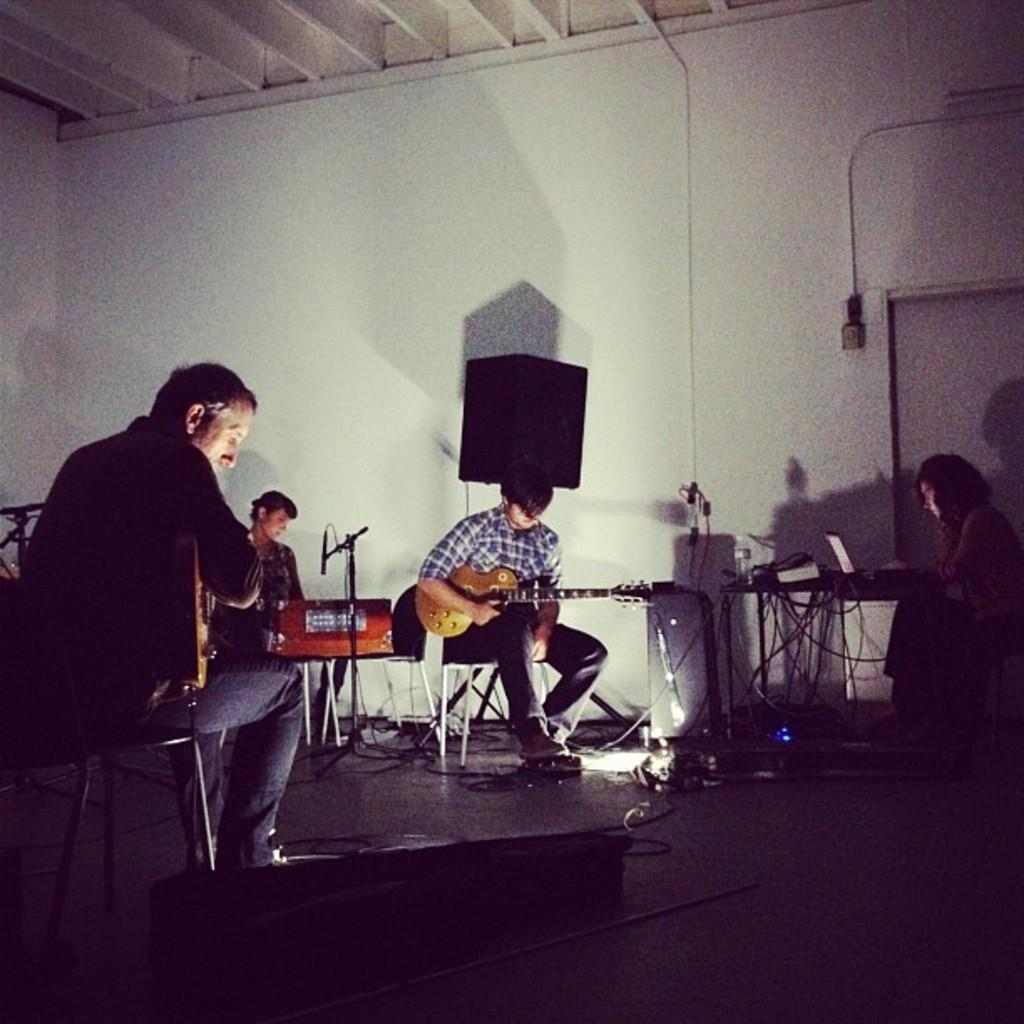What are the people in the image doing? The people in the image are sitting on chairs and holding guitars. What object is the person operating in the image? The person is operating a laptop in the image. What can be seen in the background of the image? There is a speaker in the background of the image. What type of design can be seen on the servant's uniform in the image? There is no servant present in the image, and therefore no uniform or design can be observed. 